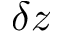Convert formula to latex. <formula><loc_0><loc_0><loc_500><loc_500>\delta z</formula> 